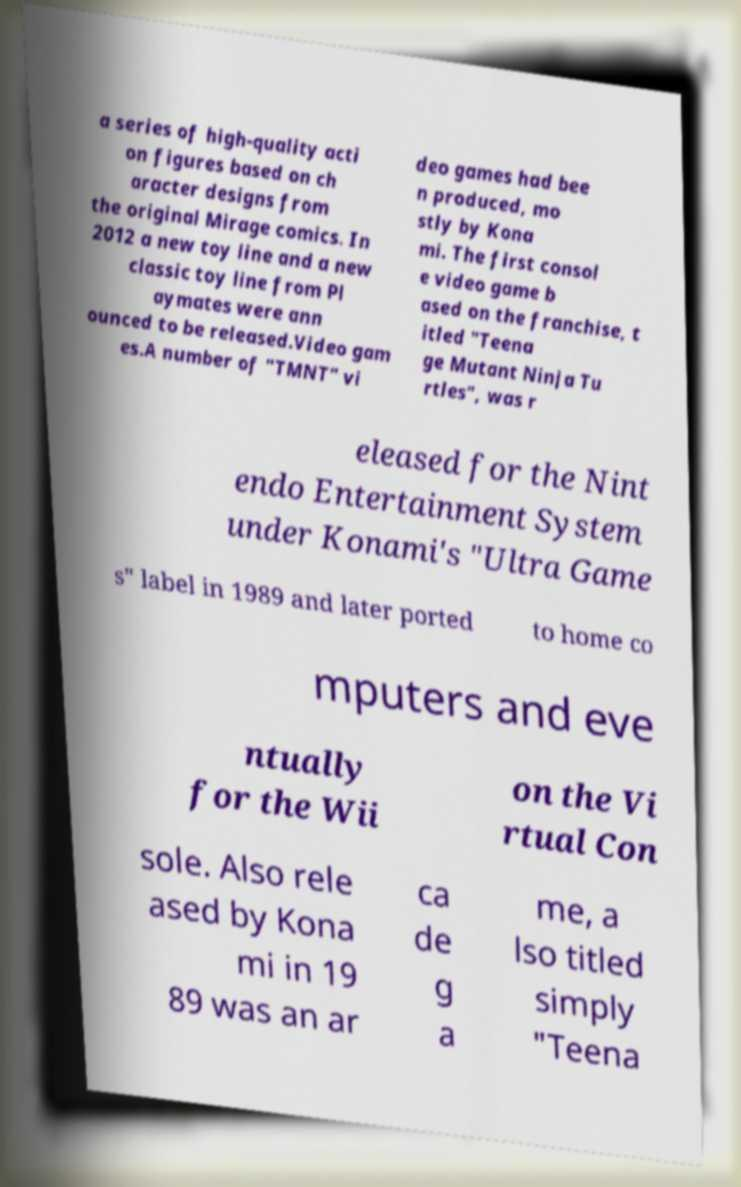For documentation purposes, I need the text within this image transcribed. Could you provide that? a series of high-quality acti on figures based on ch aracter designs from the original Mirage comics. In 2012 a new toy line and a new classic toy line from Pl aymates were ann ounced to be released.Video gam es.A number of "TMNT" vi deo games had bee n produced, mo stly by Kona mi. The first consol e video game b ased on the franchise, t itled "Teena ge Mutant Ninja Tu rtles", was r eleased for the Nint endo Entertainment System under Konami's "Ultra Game s" label in 1989 and later ported to home co mputers and eve ntually for the Wii on the Vi rtual Con sole. Also rele ased by Kona mi in 19 89 was an ar ca de g a me, a lso titled simply "Teena 